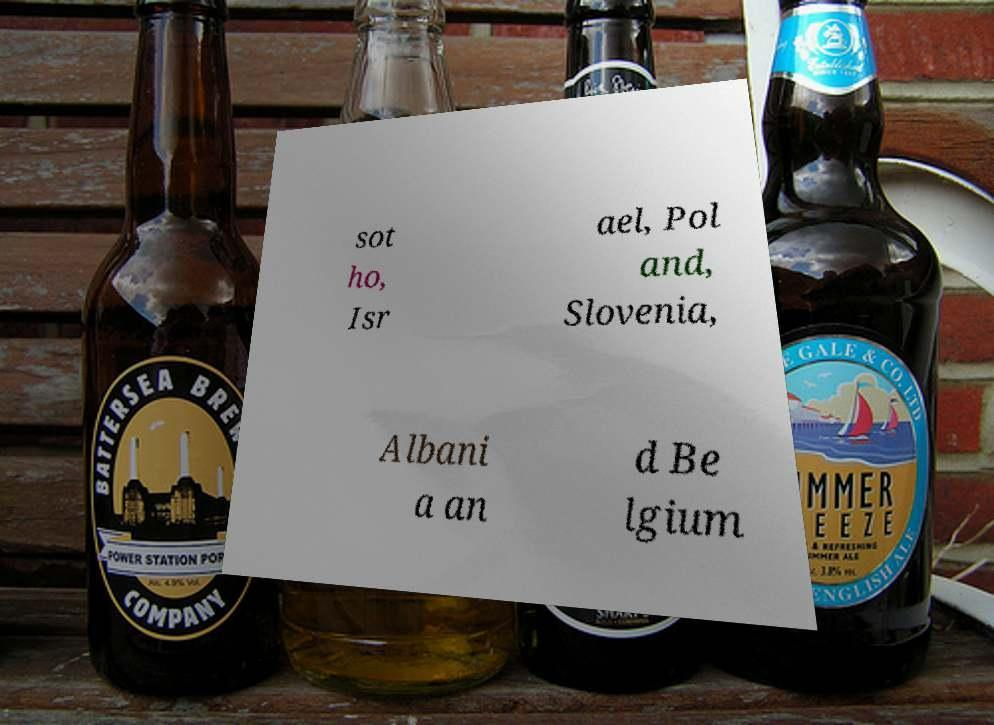What messages or text are displayed in this image? I need them in a readable, typed format. sot ho, Isr ael, Pol and, Slovenia, Albani a an d Be lgium 